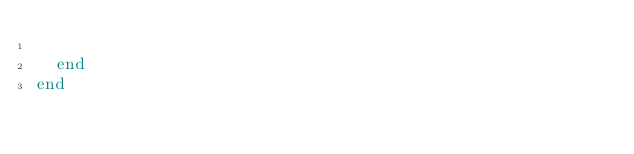<code> <loc_0><loc_0><loc_500><loc_500><_Crystal_>
  end
end

</code> 